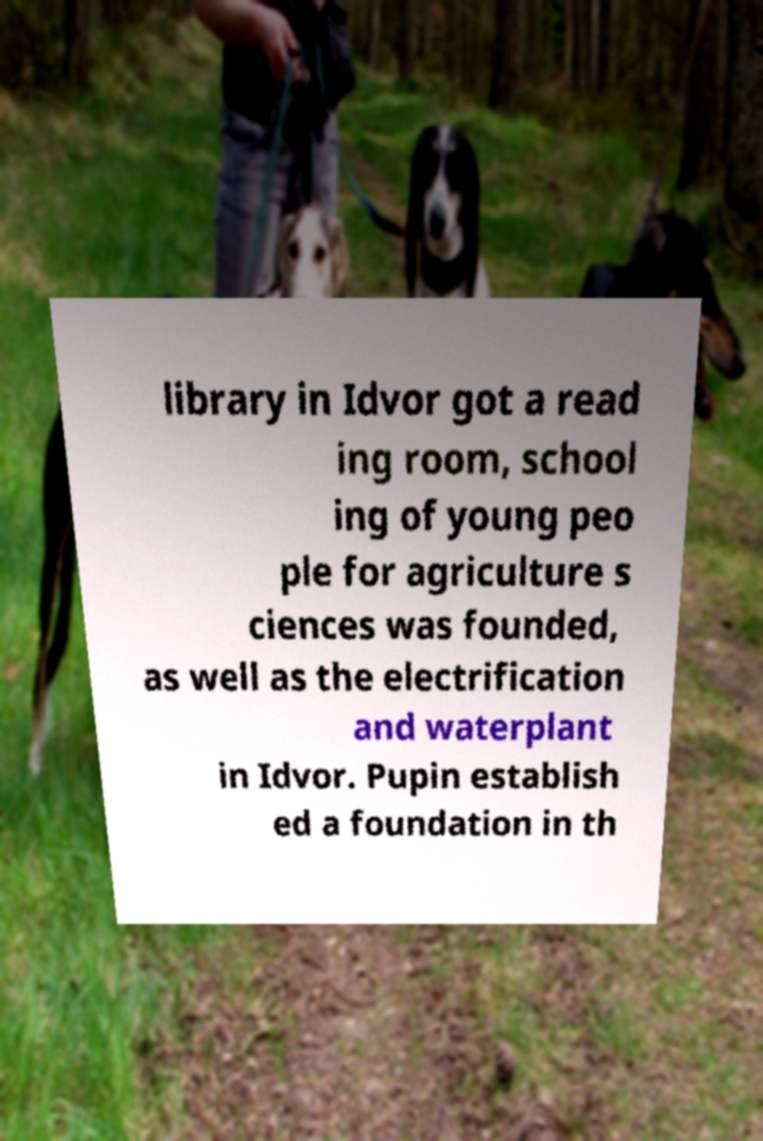Please identify and transcribe the text found in this image. library in Idvor got a read ing room, school ing of young peo ple for agriculture s ciences was founded, as well as the electrification and waterplant in Idvor. Pupin establish ed a foundation in th 